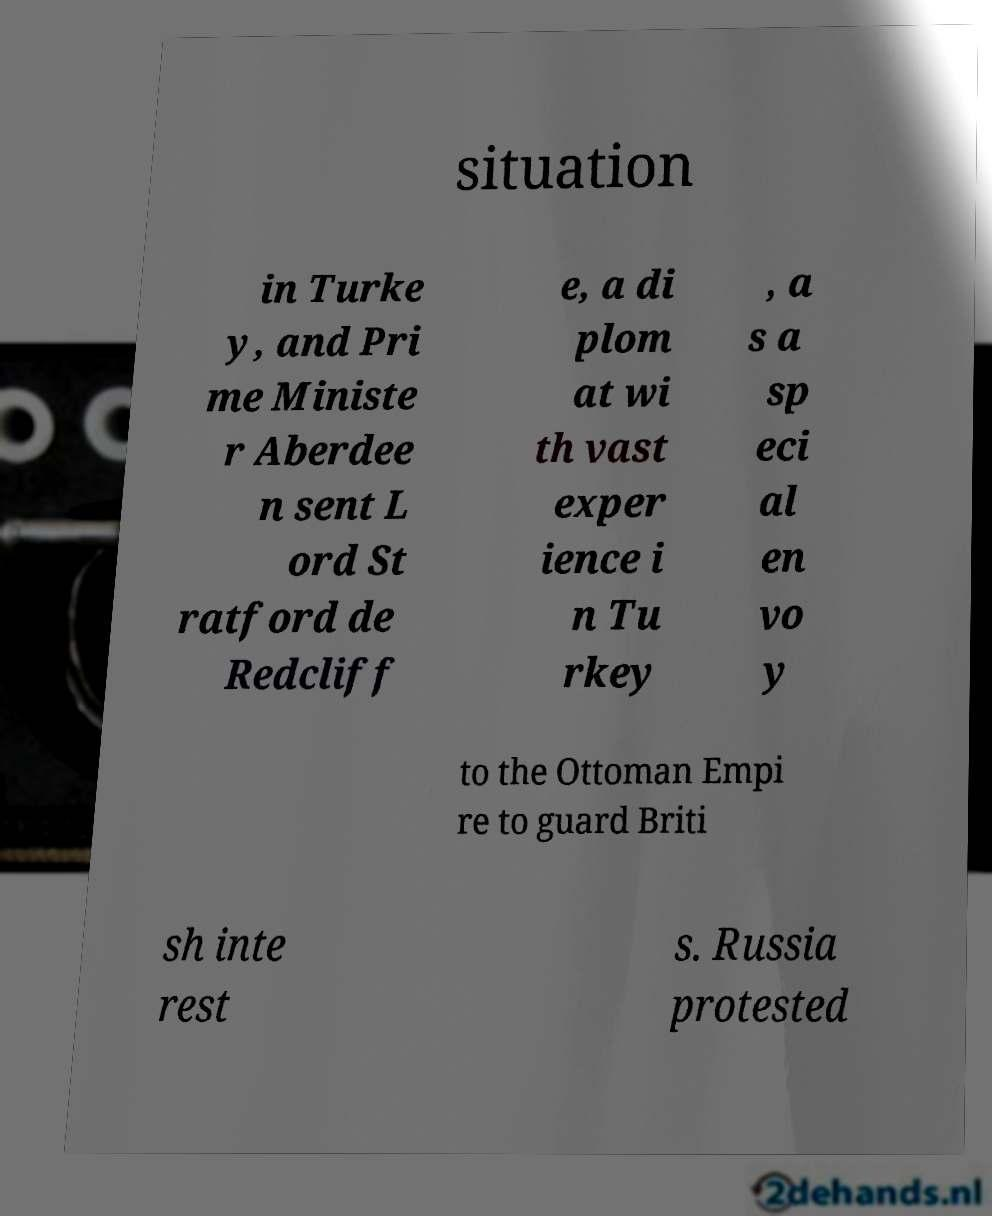What messages or text are displayed in this image? I need them in a readable, typed format. situation in Turke y, and Pri me Ministe r Aberdee n sent L ord St ratford de Redcliff e, a di plom at wi th vast exper ience i n Tu rkey , a s a sp eci al en vo y to the Ottoman Empi re to guard Briti sh inte rest s. Russia protested 